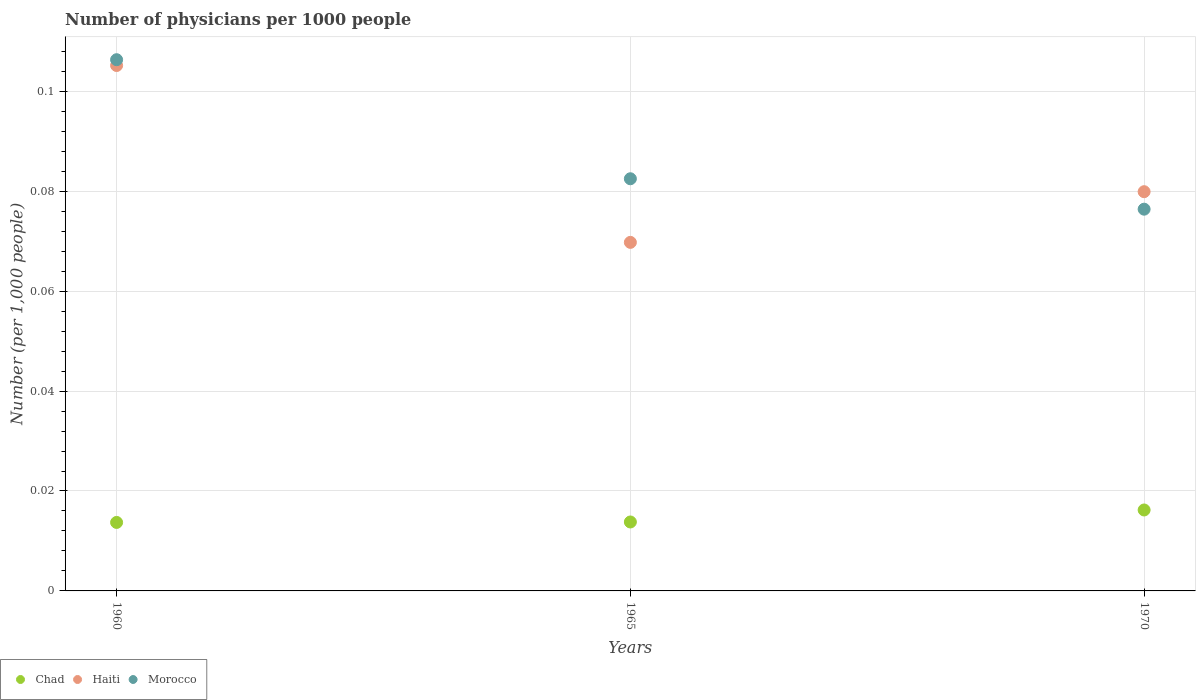How many different coloured dotlines are there?
Provide a short and direct response. 3. Is the number of dotlines equal to the number of legend labels?
Your response must be concise. Yes. What is the number of physicians in Haiti in 1960?
Your answer should be very brief. 0.11. Across all years, what is the maximum number of physicians in Chad?
Make the answer very short. 0.02. Across all years, what is the minimum number of physicians in Chad?
Offer a very short reply. 0.01. In which year was the number of physicians in Chad minimum?
Provide a short and direct response. 1960. What is the total number of physicians in Chad in the graph?
Keep it short and to the point. 0.04. What is the difference between the number of physicians in Chad in 1965 and that in 1970?
Offer a terse response. -0. What is the difference between the number of physicians in Haiti in 1960 and the number of physicians in Morocco in 1970?
Your response must be concise. 0.03. What is the average number of physicians in Haiti per year?
Give a very brief answer. 0.08. In the year 1965, what is the difference between the number of physicians in Haiti and number of physicians in Chad?
Keep it short and to the point. 0.06. In how many years, is the number of physicians in Chad greater than 0.028?
Give a very brief answer. 0. What is the ratio of the number of physicians in Haiti in 1960 to that in 1965?
Keep it short and to the point. 1.51. Is the number of physicians in Haiti in 1960 less than that in 1965?
Offer a very short reply. No. What is the difference between the highest and the second highest number of physicians in Morocco?
Provide a short and direct response. 0.02. What is the difference between the highest and the lowest number of physicians in Chad?
Offer a very short reply. 0. In how many years, is the number of physicians in Haiti greater than the average number of physicians in Haiti taken over all years?
Provide a short and direct response. 1. Is the sum of the number of physicians in Haiti in 1960 and 1970 greater than the maximum number of physicians in Morocco across all years?
Offer a very short reply. Yes. Is it the case that in every year, the sum of the number of physicians in Morocco and number of physicians in Chad  is greater than the number of physicians in Haiti?
Make the answer very short. Yes. Is the number of physicians in Chad strictly less than the number of physicians in Haiti over the years?
Provide a succinct answer. Yes. How many dotlines are there?
Your response must be concise. 3. How many years are there in the graph?
Your response must be concise. 3. Are the values on the major ticks of Y-axis written in scientific E-notation?
Offer a very short reply. No. Does the graph contain grids?
Ensure brevity in your answer.  Yes. What is the title of the graph?
Your answer should be very brief. Number of physicians per 1000 people. What is the label or title of the X-axis?
Your answer should be compact. Years. What is the label or title of the Y-axis?
Provide a succinct answer. Number (per 1,0 people). What is the Number (per 1,000 people) in Chad in 1960?
Give a very brief answer. 0.01. What is the Number (per 1,000 people) of Haiti in 1960?
Offer a terse response. 0.11. What is the Number (per 1,000 people) in Morocco in 1960?
Provide a short and direct response. 0.11. What is the Number (per 1,000 people) in Chad in 1965?
Offer a terse response. 0.01. What is the Number (per 1,000 people) in Haiti in 1965?
Offer a terse response. 0.07. What is the Number (per 1,000 people) in Morocco in 1965?
Your answer should be very brief. 0.08. What is the Number (per 1,000 people) in Chad in 1970?
Provide a succinct answer. 0.02. What is the Number (per 1,000 people) in Haiti in 1970?
Your answer should be very brief. 0.08. What is the Number (per 1,000 people) of Morocco in 1970?
Give a very brief answer. 0.08. Across all years, what is the maximum Number (per 1,000 people) in Chad?
Give a very brief answer. 0.02. Across all years, what is the maximum Number (per 1,000 people) of Haiti?
Ensure brevity in your answer.  0.11. Across all years, what is the maximum Number (per 1,000 people) of Morocco?
Your answer should be compact. 0.11. Across all years, what is the minimum Number (per 1,000 people) in Chad?
Give a very brief answer. 0.01. Across all years, what is the minimum Number (per 1,000 people) in Haiti?
Your response must be concise. 0.07. Across all years, what is the minimum Number (per 1,000 people) of Morocco?
Your answer should be very brief. 0.08. What is the total Number (per 1,000 people) of Chad in the graph?
Your answer should be very brief. 0.04. What is the total Number (per 1,000 people) of Haiti in the graph?
Offer a very short reply. 0.25. What is the total Number (per 1,000 people) in Morocco in the graph?
Provide a succinct answer. 0.27. What is the difference between the Number (per 1,000 people) in Chad in 1960 and that in 1965?
Offer a very short reply. -0. What is the difference between the Number (per 1,000 people) in Haiti in 1960 and that in 1965?
Your answer should be very brief. 0.04. What is the difference between the Number (per 1,000 people) in Morocco in 1960 and that in 1965?
Offer a terse response. 0.02. What is the difference between the Number (per 1,000 people) in Chad in 1960 and that in 1970?
Make the answer very short. -0. What is the difference between the Number (per 1,000 people) of Haiti in 1960 and that in 1970?
Keep it short and to the point. 0.03. What is the difference between the Number (per 1,000 people) in Morocco in 1960 and that in 1970?
Give a very brief answer. 0.03. What is the difference between the Number (per 1,000 people) of Chad in 1965 and that in 1970?
Your answer should be compact. -0. What is the difference between the Number (per 1,000 people) of Haiti in 1965 and that in 1970?
Provide a short and direct response. -0.01. What is the difference between the Number (per 1,000 people) in Morocco in 1965 and that in 1970?
Your response must be concise. 0.01. What is the difference between the Number (per 1,000 people) in Chad in 1960 and the Number (per 1,000 people) in Haiti in 1965?
Offer a terse response. -0.06. What is the difference between the Number (per 1,000 people) in Chad in 1960 and the Number (per 1,000 people) in Morocco in 1965?
Offer a very short reply. -0.07. What is the difference between the Number (per 1,000 people) of Haiti in 1960 and the Number (per 1,000 people) of Morocco in 1965?
Provide a succinct answer. 0.02. What is the difference between the Number (per 1,000 people) in Chad in 1960 and the Number (per 1,000 people) in Haiti in 1970?
Your answer should be compact. -0.07. What is the difference between the Number (per 1,000 people) in Chad in 1960 and the Number (per 1,000 people) in Morocco in 1970?
Make the answer very short. -0.06. What is the difference between the Number (per 1,000 people) of Haiti in 1960 and the Number (per 1,000 people) of Morocco in 1970?
Offer a terse response. 0.03. What is the difference between the Number (per 1,000 people) of Chad in 1965 and the Number (per 1,000 people) of Haiti in 1970?
Your answer should be compact. -0.07. What is the difference between the Number (per 1,000 people) of Chad in 1965 and the Number (per 1,000 people) of Morocco in 1970?
Give a very brief answer. -0.06. What is the difference between the Number (per 1,000 people) of Haiti in 1965 and the Number (per 1,000 people) of Morocco in 1970?
Your answer should be very brief. -0.01. What is the average Number (per 1,000 people) in Chad per year?
Offer a very short reply. 0.01. What is the average Number (per 1,000 people) in Haiti per year?
Offer a very short reply. 0.08. What is the average Number (per 1,000 people) of Morocco per year?
Offer a very short reply. 0.09. In the year 1960, what is the difference between the Number (per 1,000 people) in Chad and Number (per 1,000 people) in Haiti?
Ensure brevity in your answer.  -0.09. In the year 1960, what is the difference between the Number (per 1,000 people) in Chad and Number (per 1,000 people) in Morocco?
Keep it short and to the point. -0.09. In the year 1960, what is the difference between the Number (per 1,000 people) in Haiti and Number (per 1,000 people) in Morocco?
Give a very brief answer. -0. In the year 1965, what is the difference between the Number (per 1,000 people) in Chad and Number (per 1,000 people) in Haiti?
Provide a short and direct response. -0.06. In the year 1965, what is the difference between the Number (per 1,000 people) of Chad and Number (per 1,000 people) of Morocco?
Your answer should be very brief. -0.07. In the year 1965, what is the difference between the Number (per 1,000 people) of Haiti and Number (per 1,000 people) of Morocco?
Give a very brief answer. -0.01. In the year 1970, what is the difference between the Number (per 1,000 people) of Chad and Number (per 1,000 people) of Haiti?
Keep it short and to the point. -0.06. In the year 1970, what is the difference between the Number (per 1,000 people) in Chad and Number (per 1,000 people) in Morocco?
Your answer should be compact. -0.06. In the year 1970, what is the difference between the Number (per 1,000 people) in Haiti and Number (per 1,000 people) in Morocco?
Provide a succinct answer. 0. What is the ratio of the Number (per 1,000 people) in Chad in 1960 to that in 1965?
Your answer should be very brief. 0.99. What is the ratio of the Number (per 1,000 people) in Haiti in 1960 to that in 1965?
Keep it short and to the point. 1.51. What is the ratio of the Number (per 1,000 people) in Morocco in 1960 to that in 1965?
Your response must be concise. 1.29. What is the ratio of the Number (per 1,000 people) of Chad in 1960 to that in 1970?
Your answer should be compact. 0.85. What is the ratio of the Number (per 1,000 people) of Haiti in 1960 to that in 1970?
Your answer should be very brief. 1.32. What is the ratio of the Number (per 1,000 people) of Morocco in 1960 to that in 1970?
Your answer should be compact. 1.39. What is the ratio of the Number (per 1,000 people) in Chad in 1965 to that in 1970?
Make the answer very short. 0.85. What is the ratio of the Number (per 1,000 people) of Haiti in 1965 to that in 1970?
Provide a short and direct response. 0.87. What is the ratio of the Number (per 1,000 people) of Morocco in 1965 to that in 1970?
Ensure brevity in your answer.  1.08. What is the difference between the highest and the second highest Number (per 1,000 people) of Chad?
Make the answer very short. 0. What is the difference between the highest and the second highest Number (per 1,000 people) in Haiti?
Your answer should be very brief. 0.03. What is the difference between the highest and the second highest Number (per 1,000 people) in Morocco?
Ensure brevity in your answer.  0.02. What is the difference between the highest and the lowest Number (per 1,000 people) of Chad?
Give a very brief answer. 0. What is the difference between the highest and the lowest Number (per 1,000 people) of Haiti?
Your answer should be compact. 0.04. What is the difference between the highest and the lowest Number (per 1,000 people) of Morocco?
Your answer should be very brief. 0.03. 